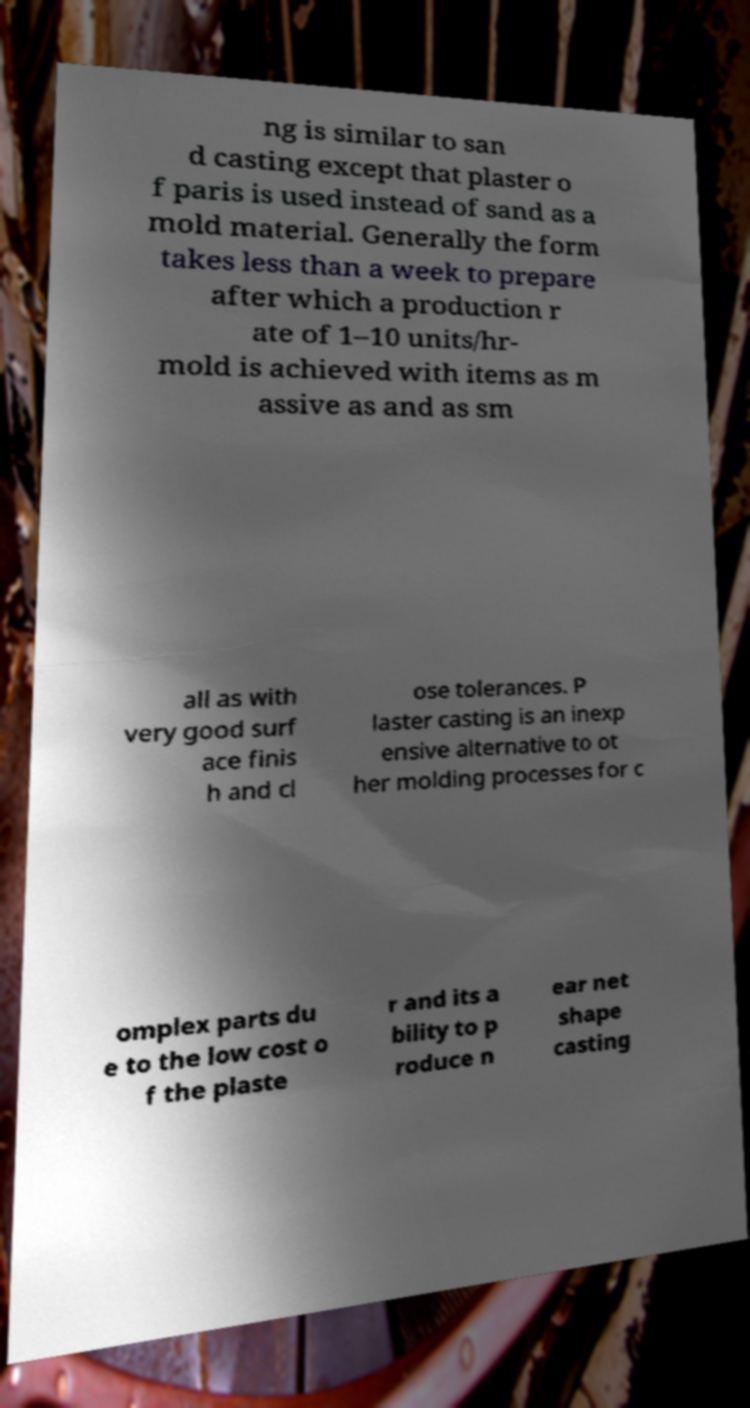There's text embedded in this image that I need extracted. Can you transcribe it verbatim? ng is similar to san d casting except that plaster o f paris is used instead of sand as a mold material. Generally the form takes less than a week to prepare after which a production r ate of 1–10 units/hr- mold is achieved with items as m assive as and as sm all as with very good surf ace finis h and cl ose tolerances. P laster casting is an inexp ensive alternative to ot her molding processes for c omplex parts du e to the low cost o f the plaste r and its a bility to p roduce n ear net shape casting 